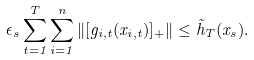<formula> <loc_0><loc_0><loc_500><loc_500>\epsilon _ { s } \sum _ { t = 1 } ^ { T } \sum _ { i = 1 } ^ { n } \| [ g _ { i , t } ( x _ { i , t } ) ] _ { + } \| \leq \tilde { h } _ { T } ( x _ { s } ) .</formula> 